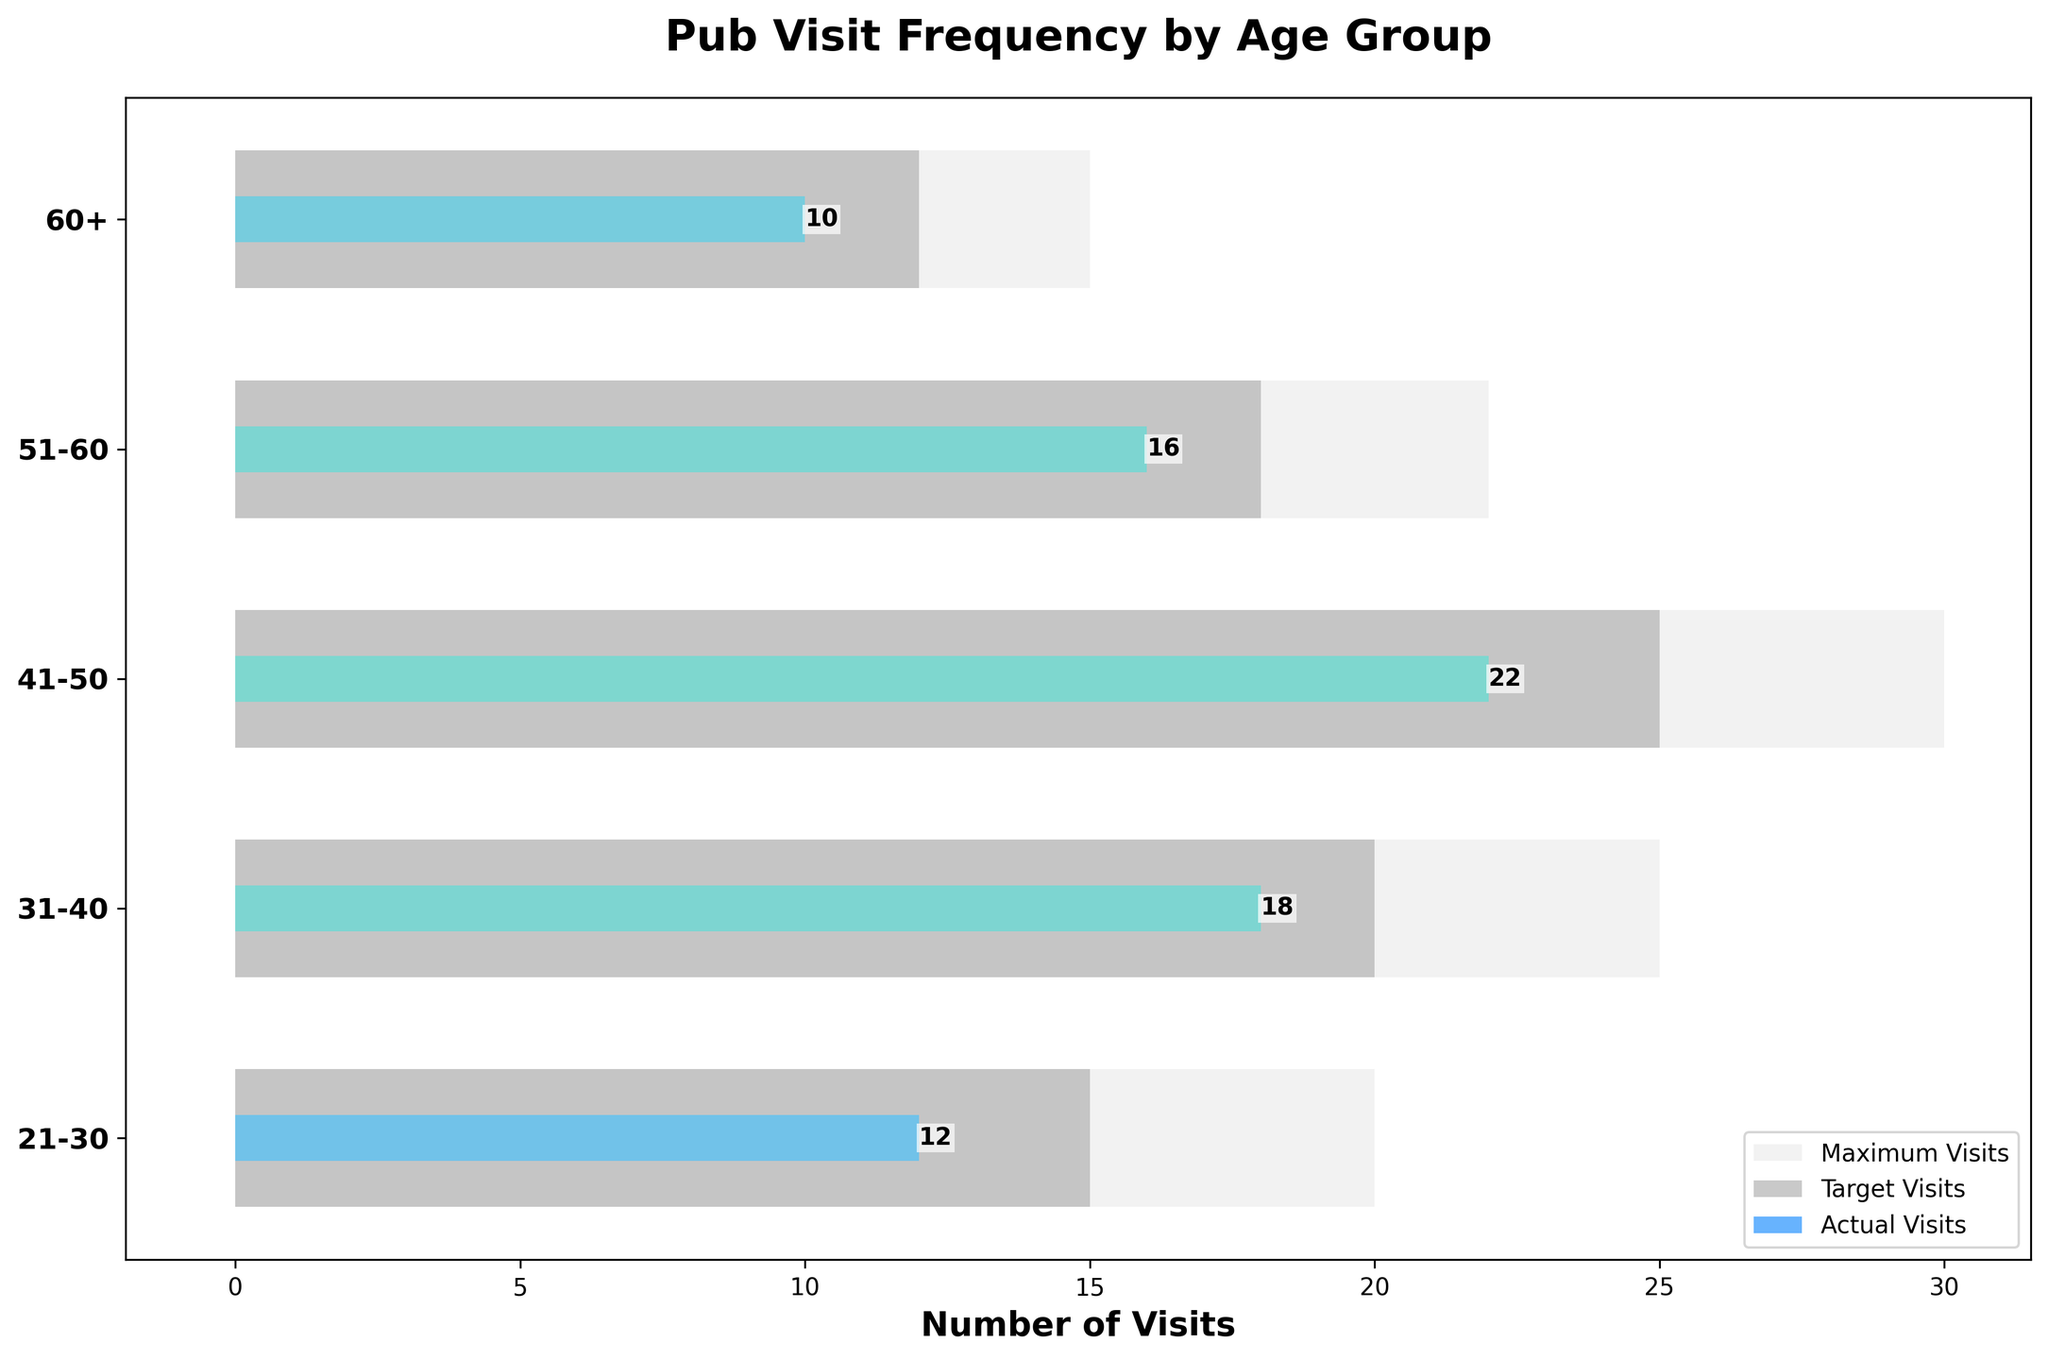What is the age group with the highest actual visits? The bar representing the actual visits for the 41-50 age group is the tallest, indicating they have the highest number of actual visits.
Answer: 41-50 What is the difference between the maximum visits and the target visits for the 31-40 age group? The maximum visits for the 31-40 age group are 25, and the target visits are 20. The difference is calculated as 25 - 20 = 5.
Answer: 5 How many age groups met or exceeded their target visits? By comparing the actual visits to the target visits, we can identify that the 21-30, 31-40, 41-50, and 51-60 age groups did not reach their target visits, while the 60+ age group also didn't meet their target.
Answer: 0 What is the total number of actual visits across all age groups? The sum of actual visits for all age groups is 12 (21-30) + 18 (31-40) + 22 (41-50) + 16 (51-60) + 10 (60+), which equals 78.
Answer: 78 Which age group has the largest gap between actual visits and target visits? The largest gap between actual and target visits can be determined by examining all age groups; for example, for 41-50 the difference is 25 - 22 = 3, and repeating similarly for the other groups shows that 21-30 age group maximally undershoots their target with 15 - 12 = 3 less.
Answer: 21-30 What percentage of the target visits did the 51-60 age group achieve? The actual visits were 16 and the target visits were 18, so the percentage is (16/18) * 100% which gives approximately 88.89%.
Answer: 88.89% Which age groups fall short of their target visits by more than 3 visits? Only 21-30 falls short of the target by exactly 3 visits (15 - 12 = 3). All other age groups fall short by a smaller margin.
Answer: 21-30 